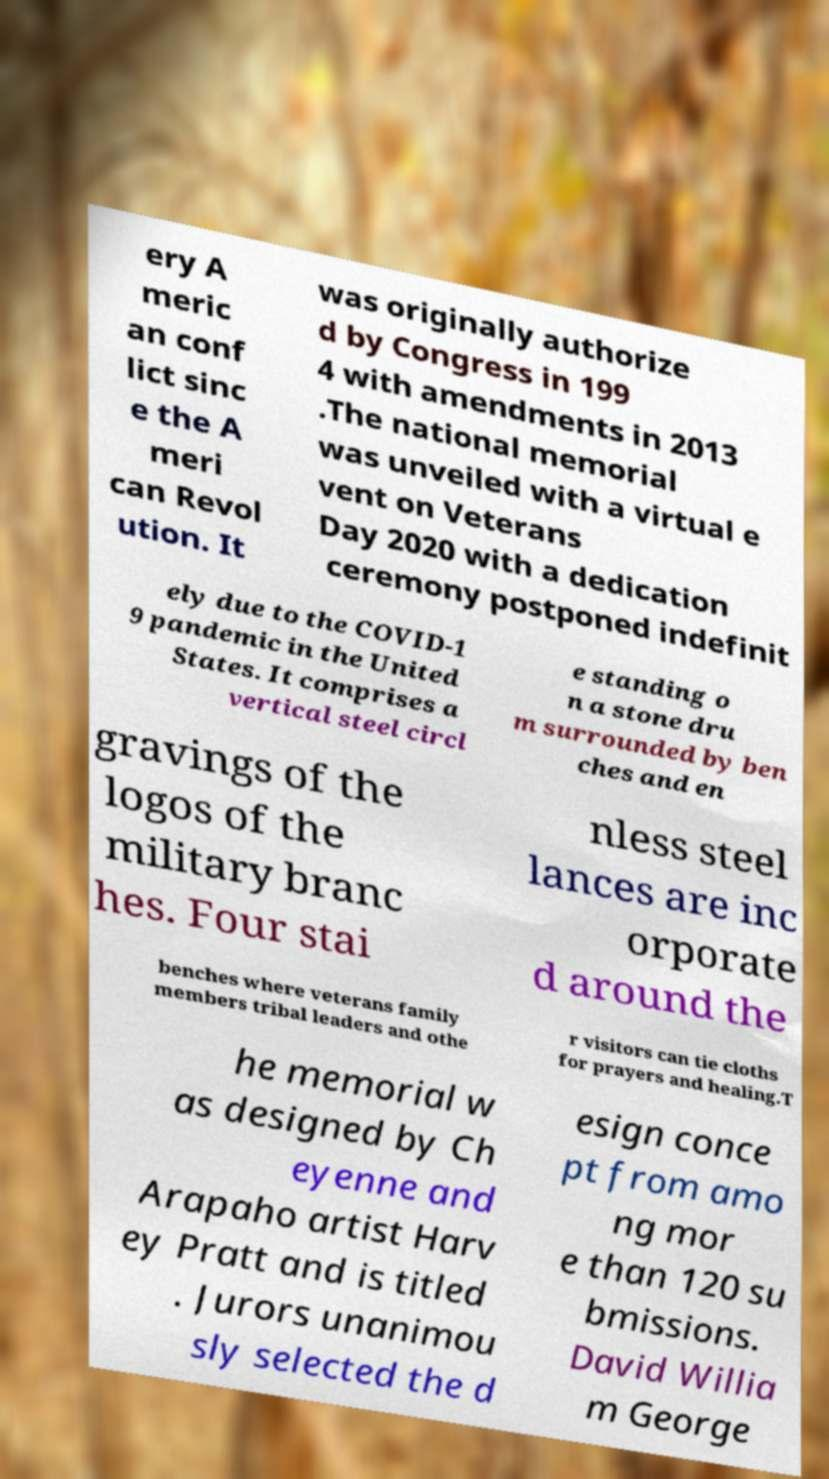What messages or text are displayed in this image? I need them in a readable, typed format. ery A meric an conf lict sinc e the A meri can Revol ution. It was originally authorize d by Congress in 199 4 with amendments in 2013 .The national memorial was unveiled with a virtual e vent on Veterans Day 2020 with a dedication ceremony postponed indefinit ely due to the COVID-1 9 pandemic in the United States. It comprises a vertical steel circl e standing o n a stone dru m surrounded by ben ches and en gravings of the logos of the military branc hes. Four stai nless steel lances are inc orporate d around the benches where veterans family members tribal leaders and othe r visitors can tie cloths for prayers and healing.T he memorial w as designed by Ch eyenne and Arapaho artist Harv ey Pratt and is titled . Jurors unanimou sly selected the d esign conce pt from amo ng mor e than 120 su bmissions. David Willia m George 